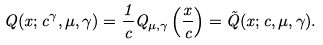<formula> <loc_0><loc_0><loc_500><loc_500>Q ( x ; c ^ { \gamma } , \mu , \gamma ) = \frac { 1 } { c } Q _ { \mu , \gamma } \left ( \frac { x } { c } \right ) = \tilde { Q } ( x ; c , \mu , \gamma ) .</formula> 